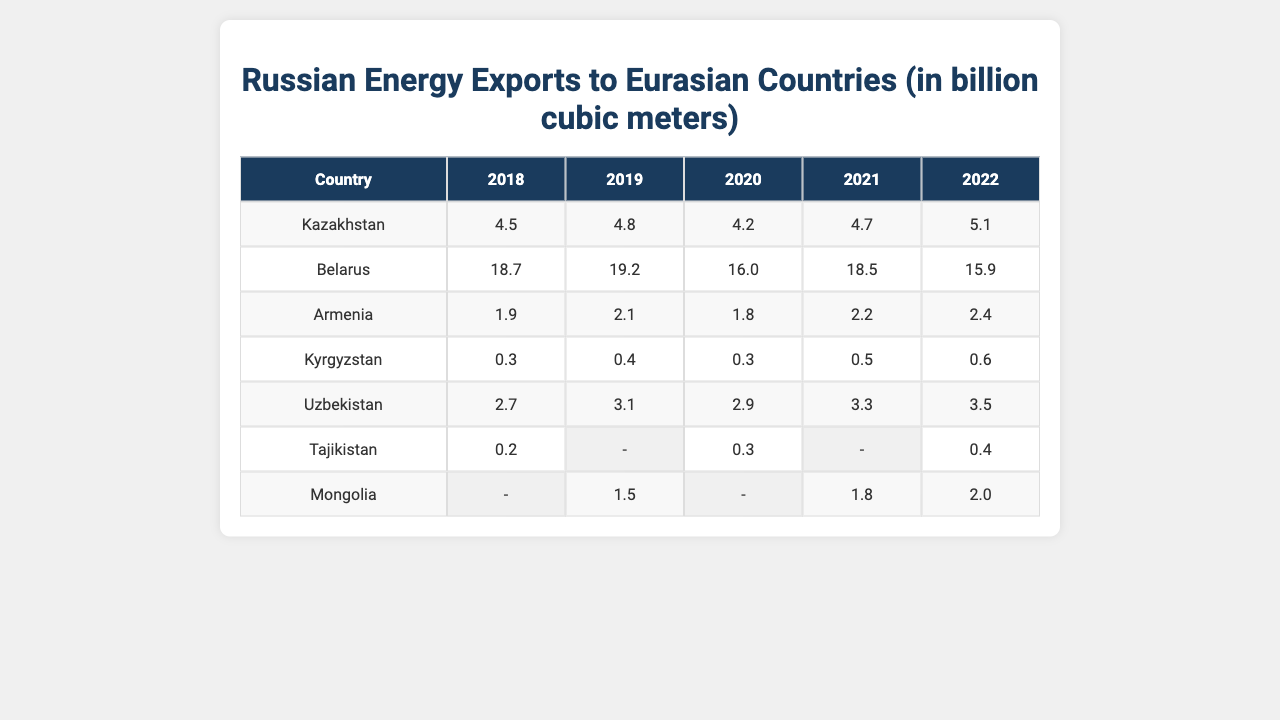What was the highest value of Russian energy exports to Belarus from 2018 to 2022? The highest value of Russian energy exports to Belarus during this period was in 2019, which is 19.2 billion cubic meters.
Answer: 19.2 Which country had the lowest energy exports in 2018? In 2018, Kyrgyzstan had the lowest energy exports with a value of 0.3 billion cubic meters.
Answer: 0.3 What is the average Russian energy export to Kazakhstan over the years provided? To find the average for Kazakhstan, add the values: (4.5 + 4.8 + 4.2 + 4.7 + 5.1) = 23.3, then divide by the 5 years: 23.3 / 5 = 4.66.
Answer: 4.66 Did Mongolia receive any Russian energy exports in 2018? No, Mongolia did not receive any Russian energy exports in 2018, as there is no data available for that year.
Answer: No What was the change in energy exports to Uzbekistan from 2018 to 2022? The energy exports to Uzbekistan increased from 2.7 billion cubic meters in 2018 to 3.5 billion cubic meters in 2022. The change is 3.5 - 2.7 = 0.8 billion cubic meters.
Answer: 0.8 Which country saw the most consistent increase in energy exports from 2018 to 2022? By observing the values, Kazakhstan shows a consistent increase from 4.5 (2018) to 5.1 (2022), thus it represents the most consistent growth in exports over the years.
Answer: Kazakhstan What was the total energy export value to Armenia from 2018 to 2022? To find the total, add the values for Armenia: 1.9 (2018) + 2.1 (2019) + 1.8 (2020) + 2.2 (2021) + 2.4 (2022) = 10.4 billion cubic meters.
Answer: 10.4 In which year did Tajikistan receive Russian energy exports, and what was the value? Tajikistan received Russian energy exports in the years 2018 (0.2), 2020 (0.3), and 2022 (0.4).
Answer: 0.2 in 2018, 0.3 in 2020, 0.4 in 2022 What was the overall trend in energy exports to Kyrgyzstan from 2018 to 2022? The overall trend shows a gradual increase from 0.3 billion cubic meters in 2018 to 0.6 in 2022, indicating consistent growth each year.
Answer: Increase Was there any decrease in energy exports to Belarus during the period provided? Yes, energy exports to Belarus decreased from 19.2 in 2019 to 15.9 in 2022, showing a decline.
Answer: Yes 